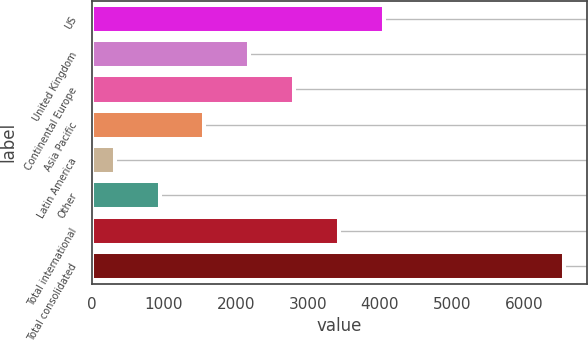Convert chart to OTSL. <chart><loc_0><loc_0><loc_500><loc_500><bar_chart><fcel>US<fcel>United Kingdom<fcel>Continental Europe<fcel>Asia Pacific<fcel>Latin America<fcel>Other<fcel>Total international<fcel>Total consolidated<nl><fcel>4058.16<fcel>2186.13<fcel>2810.14<fcel>1562.12<fcel>314.1<fcel>938.11<fcel>3434.15<fcel>6554.2<nl></chart> 